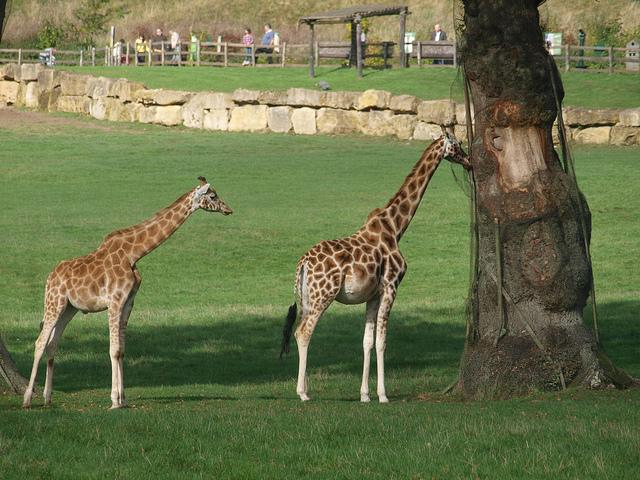How many giraffes are gathered around the tree with some mild damage?

Choices:
A) five
B) two
C) four
D) three two 